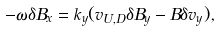<formula> <loc_0><loc_0><loc_500><loc_500>- \omega \delta B _ { x } = k _ { y } ( v _ { U , D } \delta B _ { y } - B \delta v _ { y } ) ,</formula> 